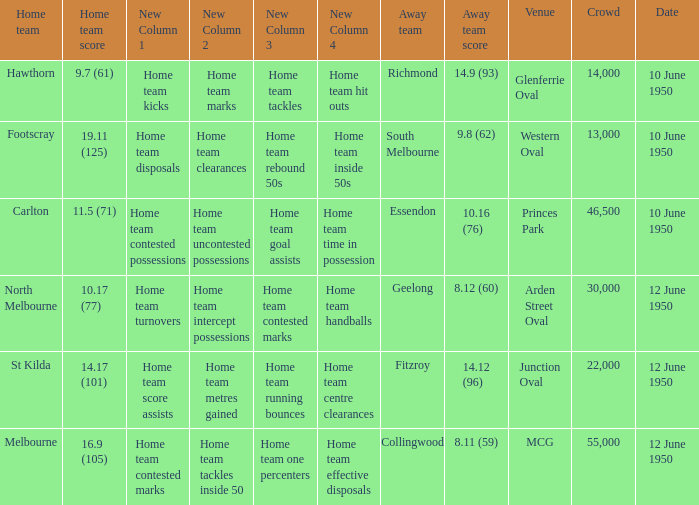Could you parse the entire table as a dict? {'header': ['Home team', 'Home team score', 'New Column 1', 'New Column 2', 'New Column 3', 'New Column 4', 'Away team', 'Away team score', 'Venue', 'Crowd', 'Date'], 'rows': [['Hawthorn', '9.7 (61)', 'Home team kicks', 'Home team marks', 'Home team tackles', 'Home team hit outs', 'Richmond', '14.9 (93)', 'Glenferrie Oval', '14,000', '10 June 1950'], ['Footscray', '19.11 (125)', 'Home team disposals', 'Home team clearances', 'Home team rebound 50s', 'Home team inside 50s', 'South Melbourne', '9.8 (62)', 'Western Oval', '13,000', '10 June 1950'], ['Carlton', '11.5 (71)', 'Home team contested possessions', 'Home team uncontested possessions', 'Home team goal assists', 'Home team time in possession', 'Essendon', '10.16 (76)', 'Princes Park', '46,500', '10 June 1950'], ['North Melbourne', '10.17 (77)', 'Home team turnovers', 'Home team intercept possessions', 'Home team contested marks', 'Home team handballs', 'Geelong', '8.12 (60)', 'Arden Street Oval', '30,000', '12 June 1950'], ['St Kilda', '14.17 (101)', 'Home team score assists', 'Home team metres gained', 'Home team running bounces', 'Home team centre clearances', 'Fitzroy', '14.12 (96)', 'Junction Oval', '22,000', '12 June 1950'], ['Melbourne', '16.9 (105)', 'Home team contested marks', 'Home team tackles inside 50', 'Home team one percenters', 'Home team effective disposals', 'Collingwood', '8.11 (59)', 'MCG', '55,000', '12 June 1950']]} What was the crowd when the VFL played MCG? 55000.0. 